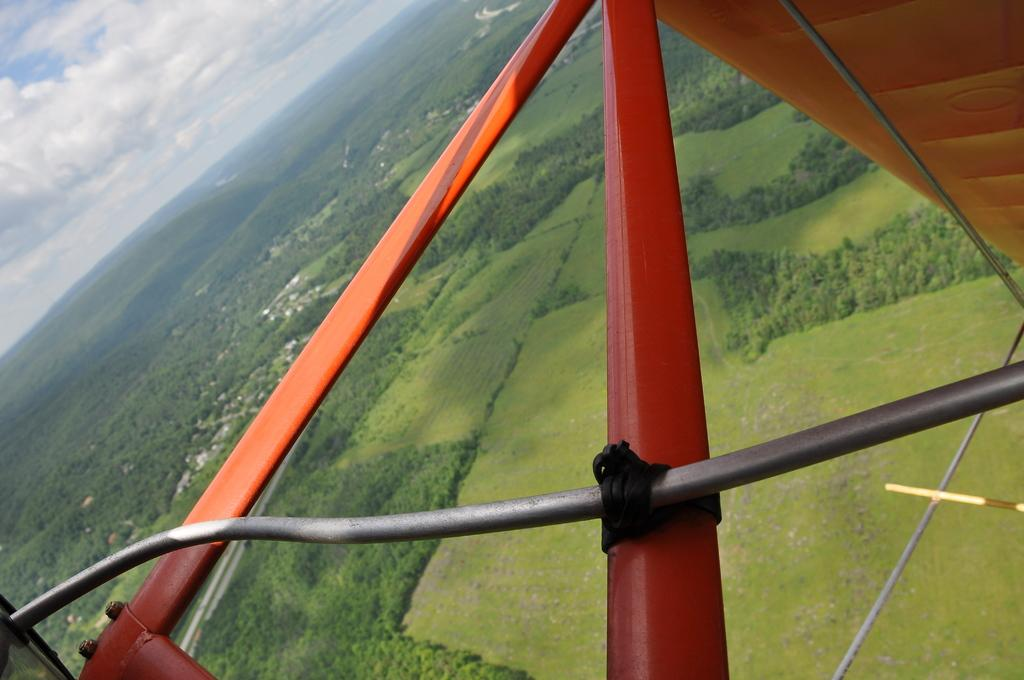What is the perspective of the image? The image is taken from an aircraft, providing a top angle view of an area. What type of vegetation can be seen on the surface in the image? There is grass on the surface in the image. What type of structures are visible in the image? There are houses in the image. What type of natural landform can be seen in the image? There are mountains in the image. What color is the wristwatch worn by the tree in the image? There are no trees wearing wristwatches in the image. 